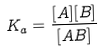Convert formula to latex. <formula><loc_0><loc_0><loc_500><loc_500>K _ { a } = \frac { [ A ] [ B ] } { [ A B ] }</formula> 